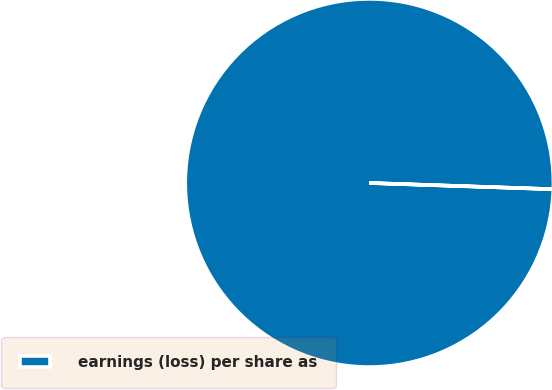Convert chart to OTSL. <chart><loc_0><loc_0><loc_500><loc_500><pie_chart><fcel>earnings (loss) per share as<nl><fcel>100.0%<nl></chart> 